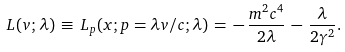<formula> <loc_0><loc_0><loc_500><loc_500>L ( v ; \lambda ) \, \equiv \, L _ { p } ( x ; p = \lambda v / c ; \lambda ) \, = \, - \, \frac { m ^ { 2 } c ^ { 4 } } { 2 \lambda } \, - \, \frac { \lambda } { 2 \gamma ^ { 2 } } .</formula> 